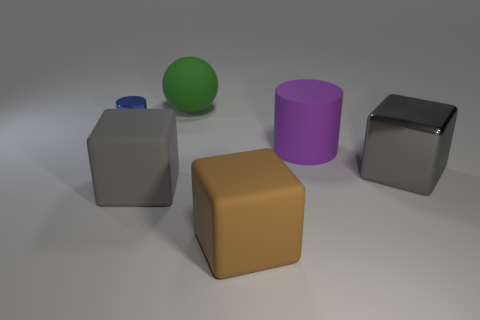Subtract all matte blocks. How many blocks are left? 1 Add 2 tiny brown cylinders. How many objects exist? 8 Subtract all spheres. How many objects are left? 5 Add 2 cylinders. How many cylinders exist? 4 Subtract 0 red cylinders. How many objects are left? 6 Subtract all large brown matte cylinders. Subtract all metal cylinders. How many objects are left? 5 Add 1 rubber cylinders. How many rubber cylinders are left? 2 